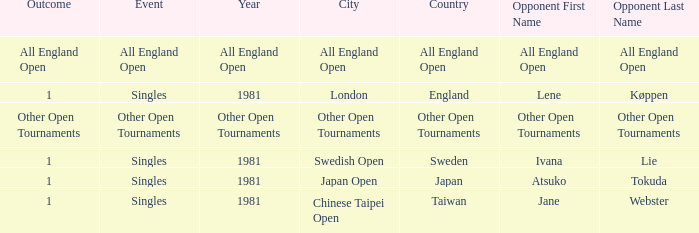What is the Outcome of the Singles Event in London, England? 1.0. 